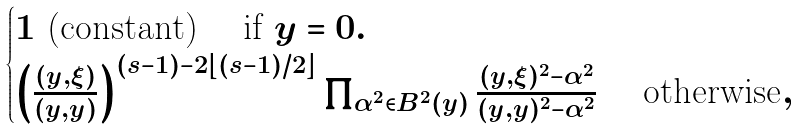<formula> <loc_0><loc_0><loc_500><loc_500>\begin{cases} 1 \text { (constant) } \text {\quad if $y =0$} . \\ \left ( \frac { ( y , \xi ) } { ( y , y ) } \right ) ^ { ( s - 1 ) - 2 \lfloor ( s - 1 ) / 2 \rfloor } \prod _ { \alpha ^ { 2 } \in B ^ { 2 } ( y ) } \frac { ( y , \xi ) ^ { 2 } - \alpha ^ { 2 } } { ( y , y ) ^ { 2 } - \alpha ^ { 2 } } \text { \quad otherwise} , \end{cases}</formula> 